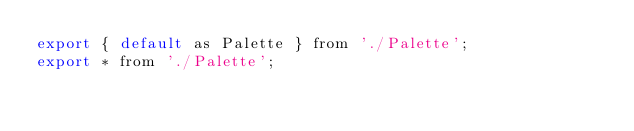Convert code to text. <code><loc_0><loc_0><loc_500><loc_500><_JavaScript_>export { default as Palette } from './Palette';
export * from './Palette';
</code> 